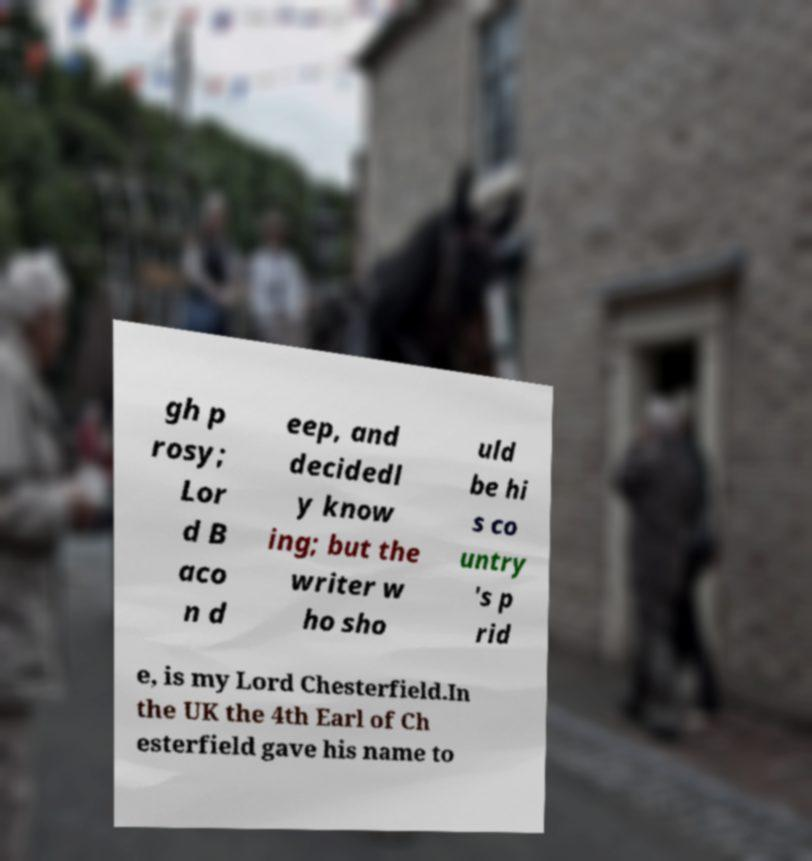Please read and relay the text visible in this image. What does it say? gh p rosy; Lor d B aco n d eep, and decidedl y know ing; but the writer w ho sho uld be hi s co untry 's p rid e, is my Lord Chesterfield.In the UK the 4th Earl of Ch esterfield gave his name to 